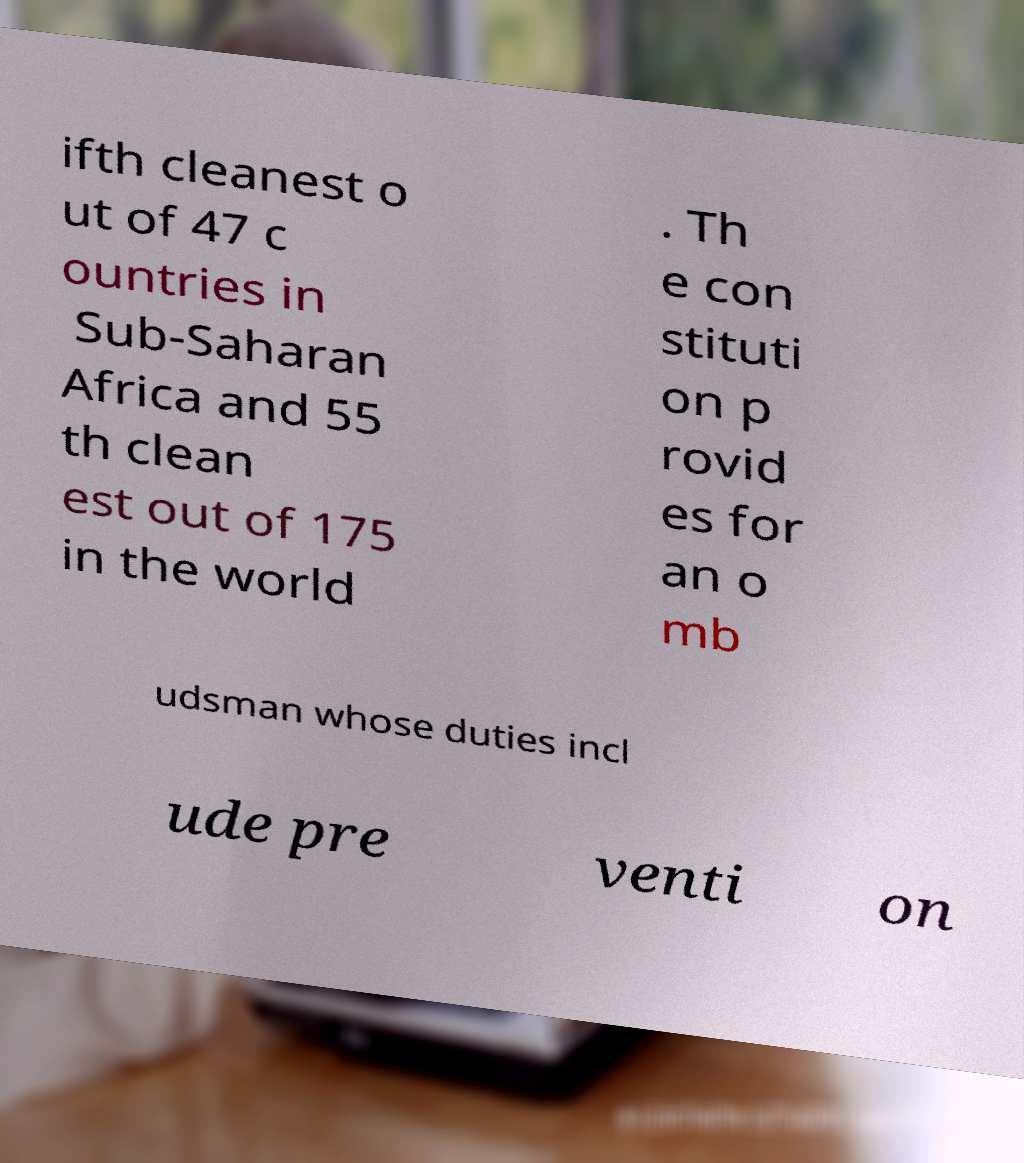For documentation purposes, I need the text within this image transcribed. Could you provide that? ifth cleanest o ut of 47 c ountries in Sub-Saharan Africa and 55 th clean est out of 175 in the world . Th e con stituti on p rovid es for an o mb udsman whose duties incl ude pre venti on 